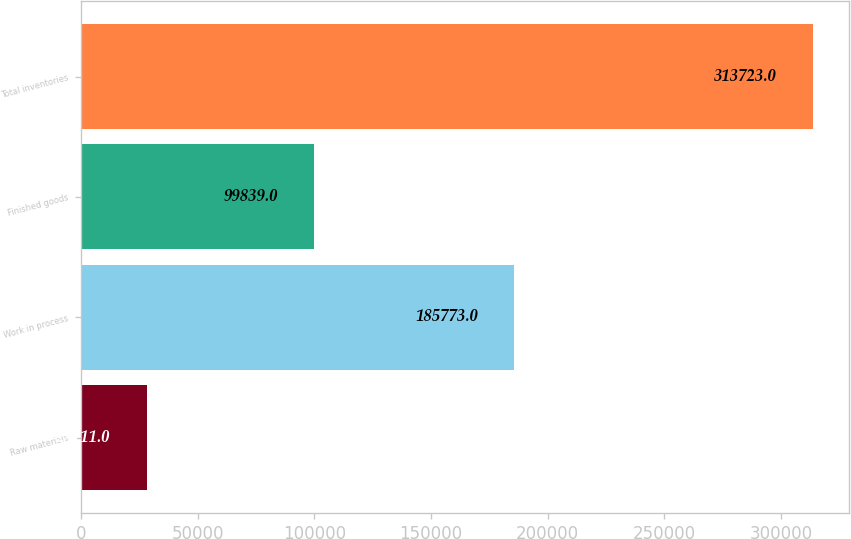Convert chart. <chart><loc_0><loc_0><loc_500><loc_500><bar_chart><fcel>Raw materials<fcel>Work in process<fcel>Finished goods<fcel>Total inventories<nl><fcel>28111<fcel>185773<fcel>99839<fcel>313723<nl></chart> 